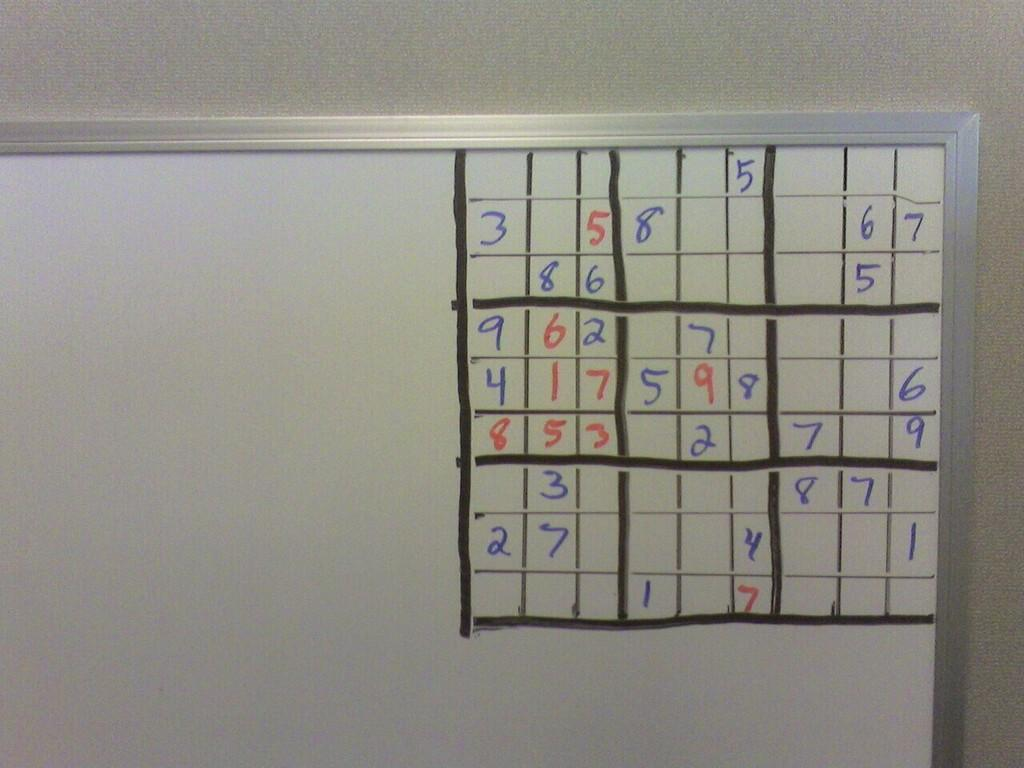<image>
Create a compact narrative representing the image presented. Sudoku boxes being filled in on a board with a number 3 being the top left most number. 